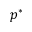<formula> <loc_0><loc_0><loc_500><loc_500>p ^ { * }</formula> 